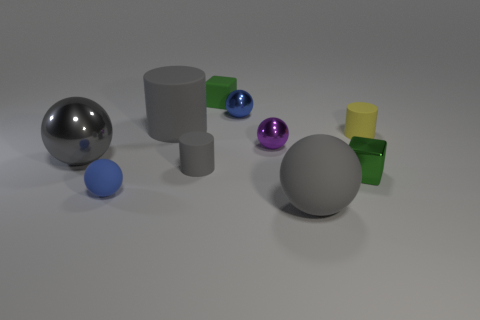Subtract all large gray rubber spheres. How many spheres are left? 4 Subtract all gray cylinders. How many cylinders are left? 1 Subtract all cubes. How many objects are left? 8 Subtract 1 cylinders. How many cylinders are left? 2 Subtract all red blocks. Subtract all cyan cylinders. How many blocks are left? 2 Subtract all yellow spheres. How many blue cylinders are left? 0 Subtract all tiny purple matte balls. Subtract all spheres. How many objects are left? 5 Add 3 gray shiny spheres. How many gray shiny spheres are left? 4 Add 1 small shiny blocks. How many small shiny blocks exist? 2 Subtract 0 green spheres. How many objects are left? 10 